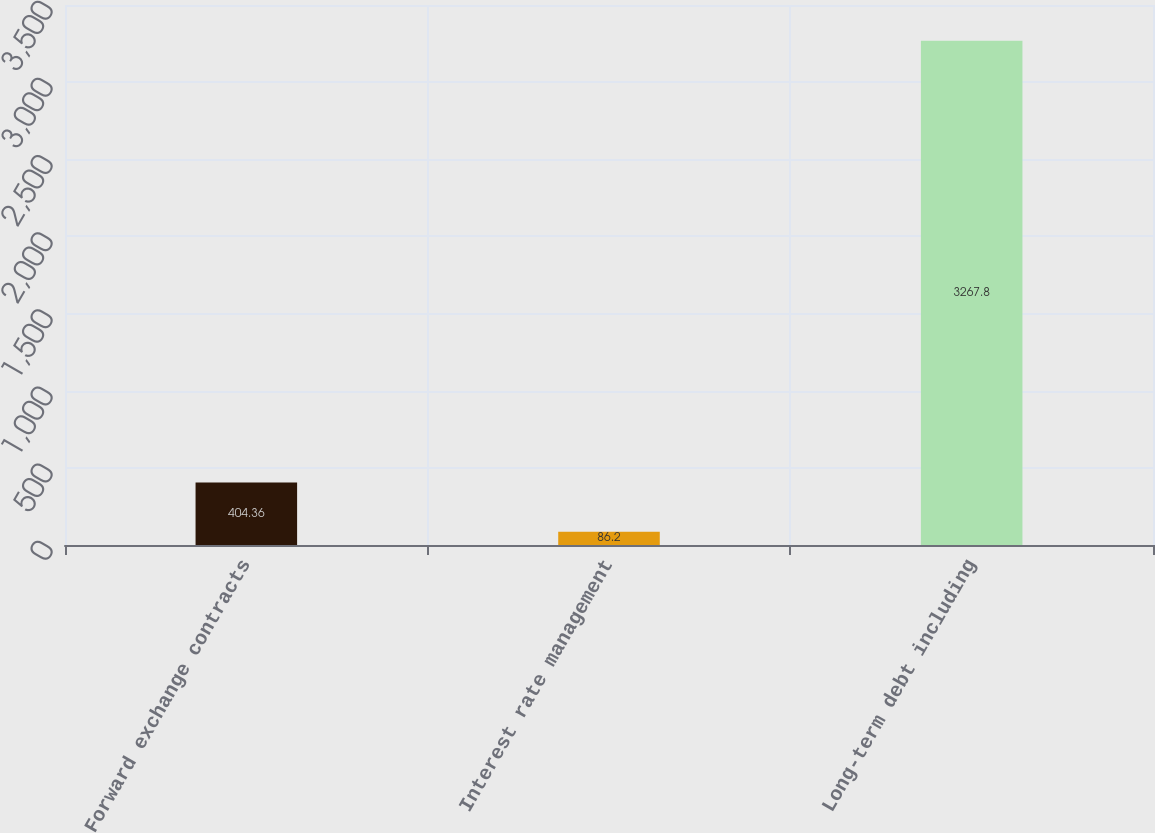Convert chart. <chart><loc_0><loc_0><loc_500><loc_500><bar_chart><fcel>Forward exchange contracts<fcel>Interest rate management<fcel>Long-term debt including<nl><fcel>404.36<fcel>86.2<fcel>3267.8<nl></chart> 